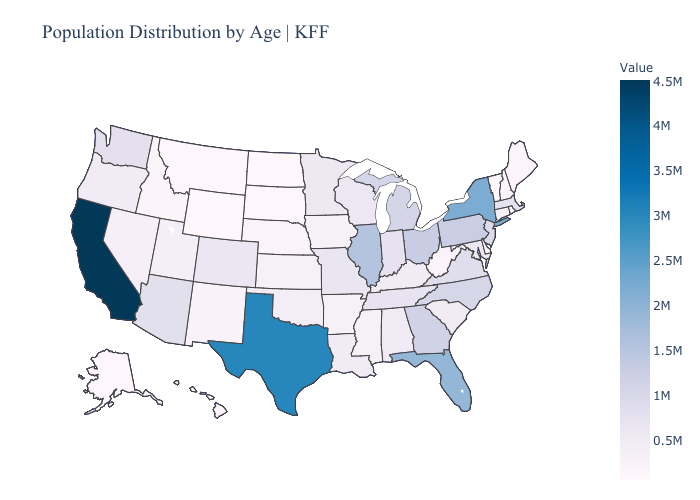Does Hawaii have the lowest value in the USA?
Keep it brief. No. Which states have the highest value in the USA?
Short answer required. California. Which states have the highest value in the USA?
Give a very brief answer. California. Among the states that border Louisiana , which have the highest value?
Be succinct. Texas. Does California have the highest value in the USA?
Quick response, please. Yes. Which states have the highest value in the USA?
Keep it brief. California. Among the states that border North Carolina , which have the highest value?
Be succinct. Georgia. 